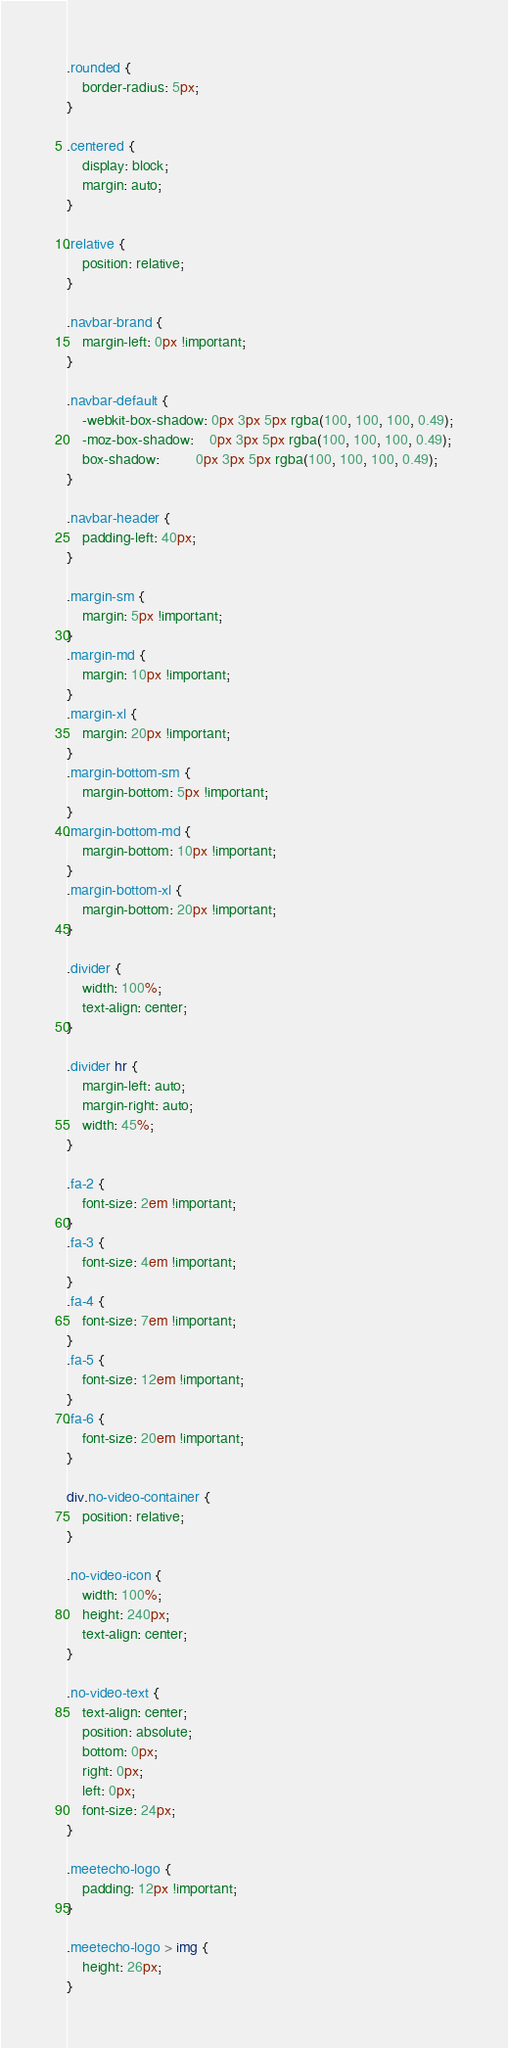Convert code to text. <code><loc_0><loc_0><loc_500><loc_500><_CSS_>.rounded {
	border-radius: 5px;
}

.centered {
	display: block;
	margin: auto;
}

.relative {
	position: relative;
}

.navbar-brand {
	margin-left: 0px !important;
}

.navbar-default {
	-webkit-box-shadow: 0px 3px 5px rgba(100, 100, 100, 0.49);
	-moz-box-shadow:    0px 3px 5px rgba(100, 100, 100, 0.49);
	box-shadow:         0px 3px 5px rgba(100, 100, 100, 0.49);
}

.navbar-header {
	padding-left: 40px;
}

.margin-sm {
	margin: 5px !important;
}
.margin-md {
	margin: 10px !important;
}
.margin-xl {
	margin: 20px !important;
}
.margin-bottom-sm {
	margin-bottom: 5px !important;
}
.margin-bottom-md {
	margin-bottom: 10px !important;
}
.margin-bottom-xl {
	margin-bottom: 20px !important;
}

.divider {
	width: 100%;
	text-align: center;
}

.divider hr {
	margin-left: auto;
	margin-right: auto;
	width: 45%;
}

.fa-2 {
	font-size: 2em !important;
}
.fa-3 {
	font-size: 4em !important;
}
.fa-4 {
	font-size: 7em !important;
}
.fa-5 {
	font-size: 12em !important;
}
.fa-6 {
	font-size: 20em !important;
}

div.no-video-container {
	position: relative;
}

.no-video-icon {
	width: 100%;
	height: 240px;
	text-align: center;
}

.no-video-text {
	text-align: center;
	position: absolute;
	bottom: 0px;
	right: 0px;
	left: 0px;
	font-size: 24px;
}

.meetecho-logo {
	padding: 12px !important;
}

.meetecho-logo > img {
	height: 26px;
}
</code> 